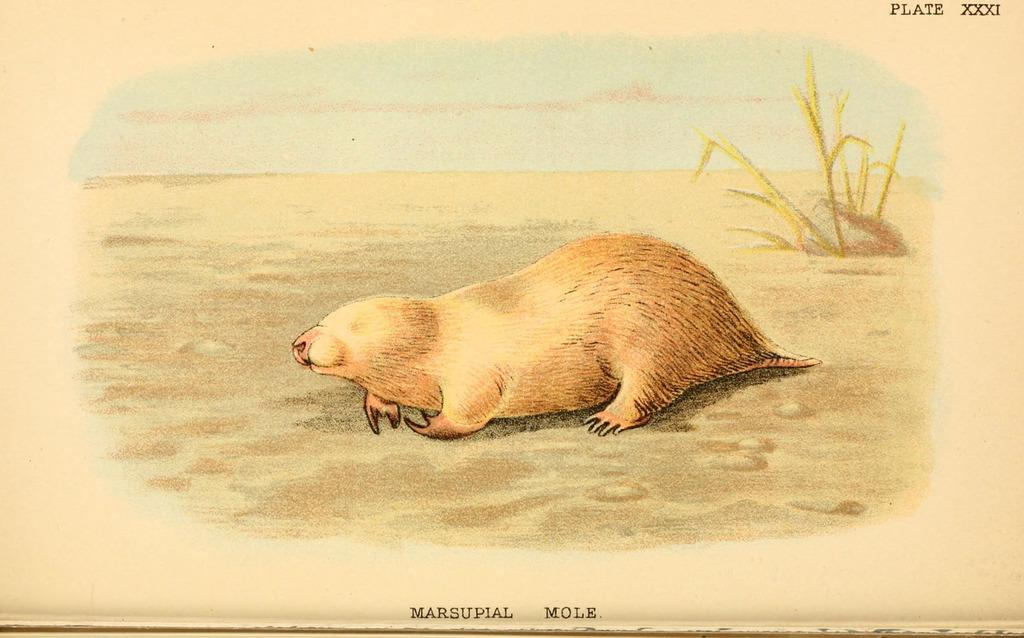What is depicted in the painting in the image? There is a painting of an animal and a painting of a plant in the image. What is the setting of the painting? Water is depicted in the painting. Is there any text or writing on the image? Yes, there is something written on the image. How does the animal in the painting digest its food? The animal in the painting does not have any digestive processes, as it is a two-dimensional representation in a painting. 